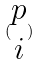<formula> <loc_0><loc_0><loc_500><loc_500>( \begin{matrix} p \\ i \end{matrix} )</formula> 